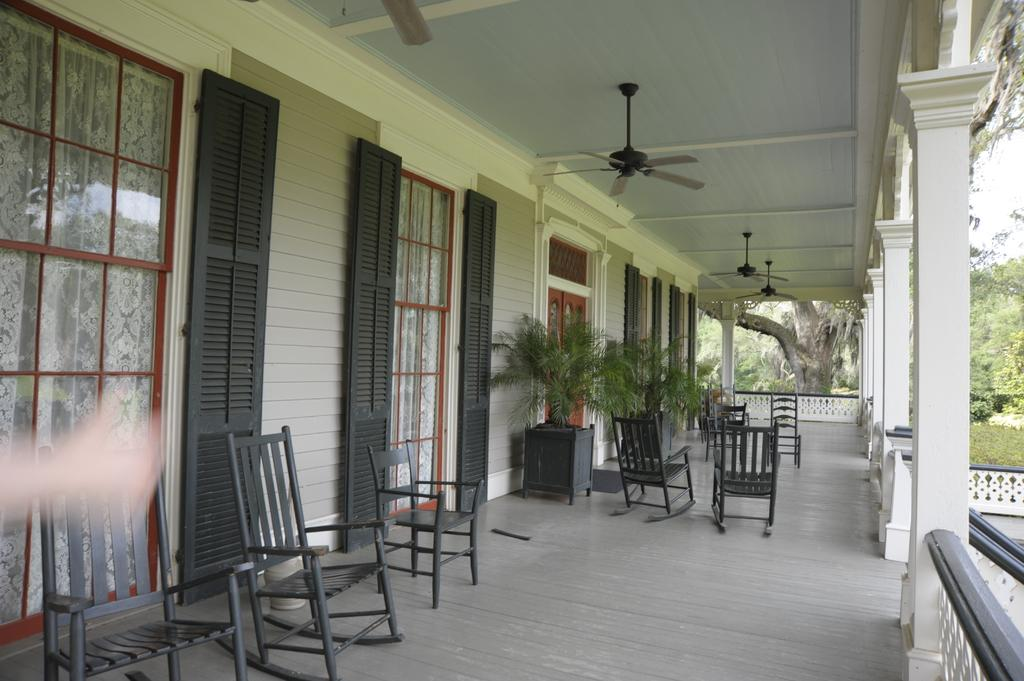What type of furniture is on the floor in the image? There are chairs on the floor in the image. What type of living organisms can be seen in the image? Plants are visible in the image. What architectural features can be seen in the image? Doors, windows with curtains, fans, pillars, and trees in the background are visible in the image. Can you describe the behavior of the zebra in the image? There is no zebra present in the image, so it is not possible to describe its behavior. What type of teeth does the fang in the image have? There is no fang present in the image, so it is not possible to describe its teeth. 